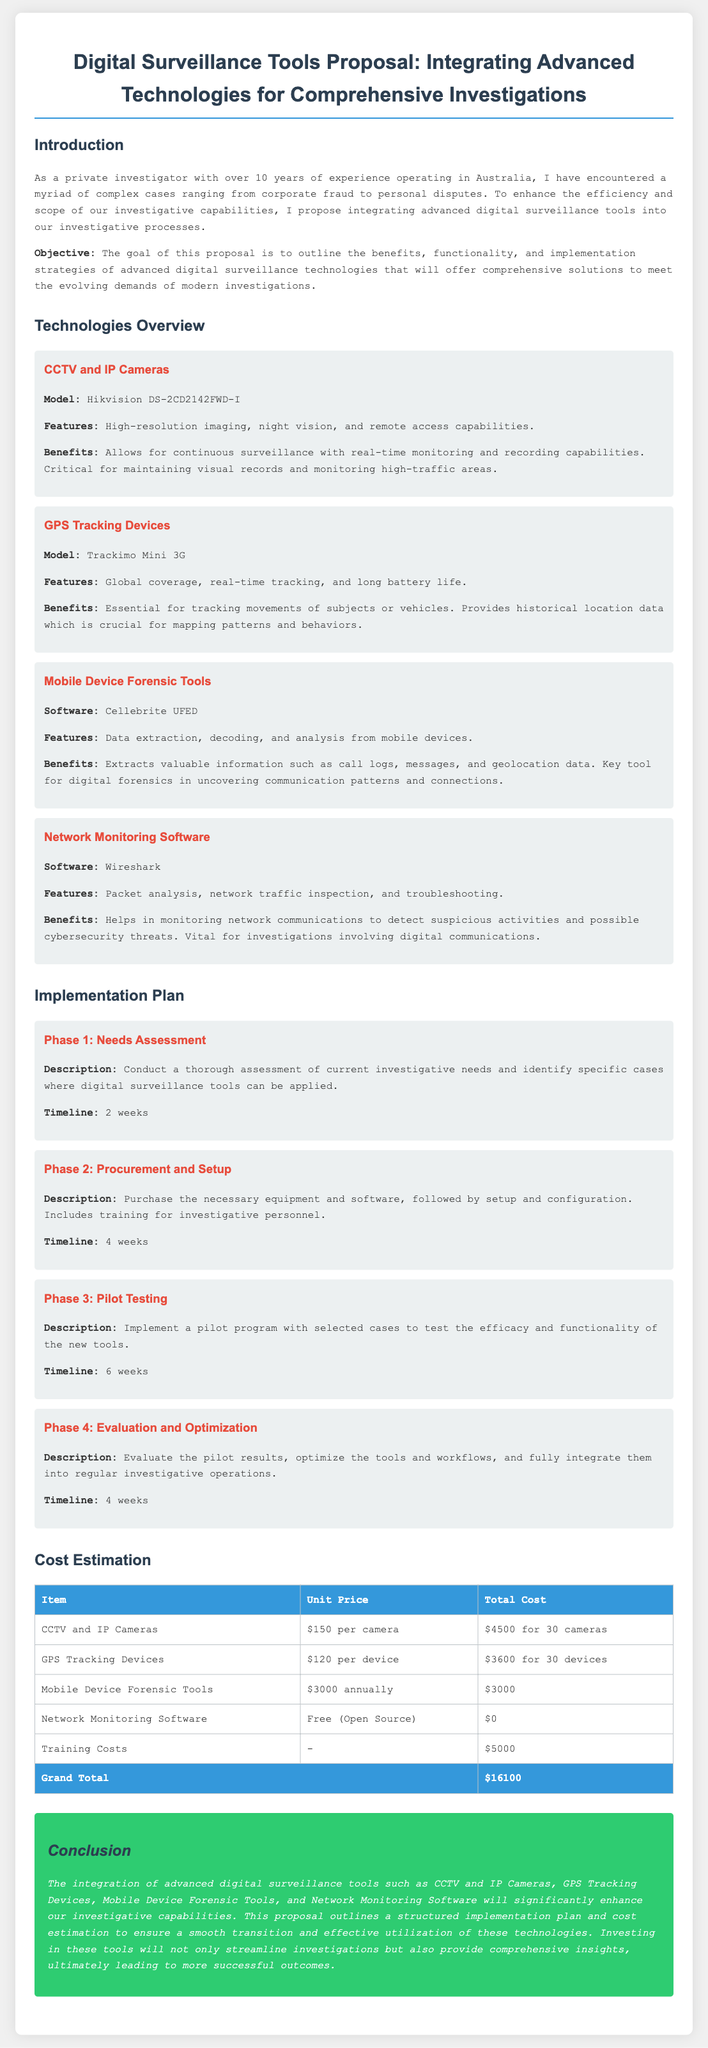What is the model of the CCTV camera? The document states the model of the CCTV camera as Hikvision DS-2CD2142FWD-I.
Answer: Hikvision DS-2CD2142FWD-I What is included in Phase 1 of the implementation plan? Phase 1 of the implementation plan includes conducting a thorough assessment of current investigative needs and identifying specific cases where digital surveillance tools can be applied.
Answer: Needs Assessment What is the total cost for the GPS Tracking Devices? The total cost for the GPS Tracking Devices is stated as $3600 for 30 devices.
Answer: $3600 for 30 devices How long does the pilot testing phase last? The duration of Phase 3, Pilot Testing, is provided in the document as 6 weeks.
Answer: 6 weeks What type of software is used for Mobile Device Forensic Tools? The document specifies the software used for Mobile Device Forensic Tools as Cellebrite UFED.
Answer: Cellebrite UFED What is the grand total cost of the proposal? The document summarizes the overall financial details, concluding with a grand total cost of $16100.
Answer: $16100 What is the main objective of the proposal? The objective outlined in the proposal is to enhance the efficiency and scope of investigative capabilities through advanced digital surveillance tools.
Answer: Enhance efficiency and scope How many cameras are proposed for purchase? The document mentions purchasing 30 cameras as part of the digital surveillance tools proposal.
Answer: 30 cameras What is the benefit of using GPS Tracking Devices? The document highlights that GPS Tracking Devices are essential for tracking movements and mapping patterns and behaviors.
Answer: Tracking movements and mapping patterns 